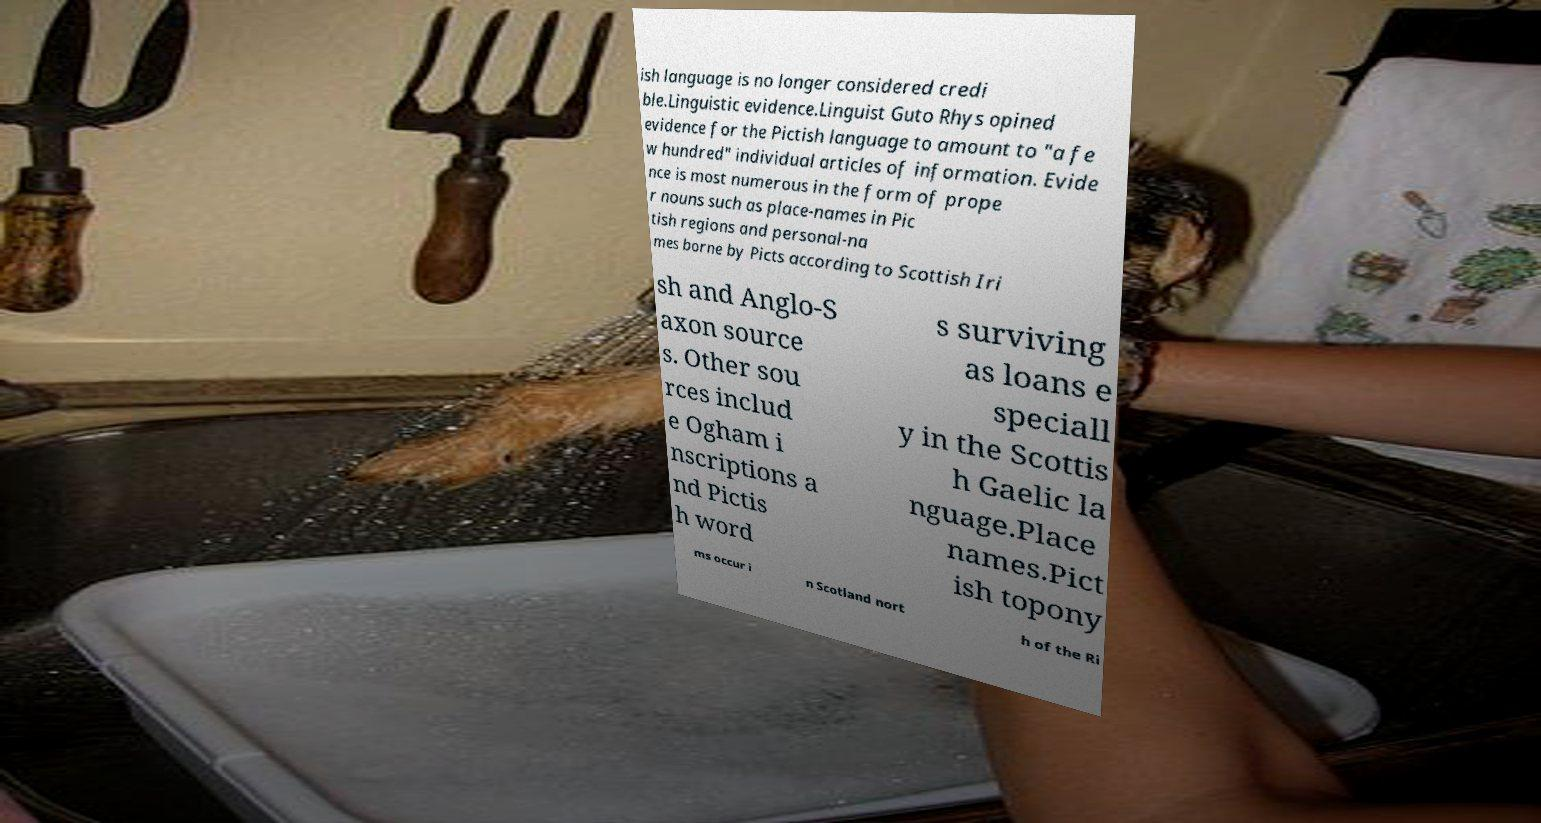Please read and relay the text visible in this image. What does it say? ish language is no longer considered credi ble.Linguistic evidence.Linguist Guto Rhys opined evidence for the Pictish language to amount to "a fe w hundred" individual articles of information. Evide nce is most numerous in the form of prope r nouns such as place-names in Pic tish regions and personal-na mes borne by Picts according to Scottish Iri sh and Anglo-S axon source s. Other sou rces includ e Ogham i nscriptions a nd Pictis h word s surviving as loans e speciall y in the Scottis h Gaelic la nguage.Place names.Pict ish topony ms occur i n Scotland nort h of the Ri 